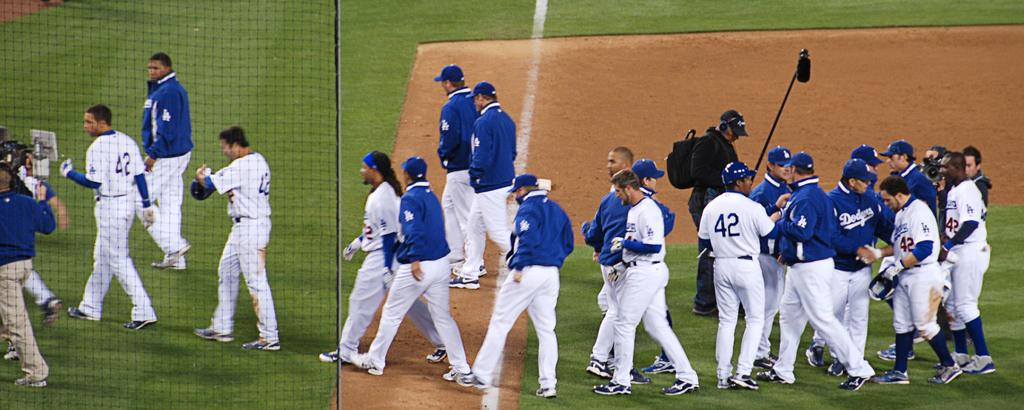<image>
Summarize the visual content of the image. A group of Dodgers players and others standing on a baseball diamond 